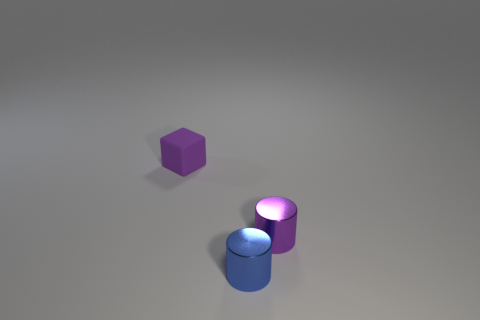Add 2 small blue cylinders. How many objects exist? 5 Subtract all blocks. How many objects are left? 2 Add 2 purple cylinders. How many purple cylinders exist? 3 Subtract 0 gray balls. How many objects are left? 3 Subtract all rubber blocks. Subtract all small blue rubber objects. How many objects are left? 2 Add 3 tiny blue shiny cylinders. How many tiny blue shiny cylinders are left? 4 